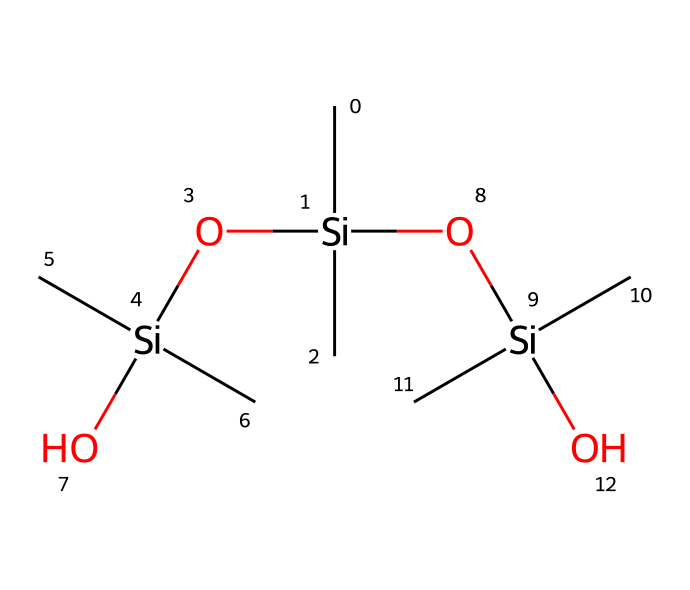What is the main functional group present in this chemical? The chemical structure contains multiple silicon atoms bonded to oxygen atoms, which is characteristic of silanol functional groups. The oxygen bonded to silicon indicates the presence of these groups.
Answer: silanol How many silicon atoms are present in the chemical structure? By analyzing the SMILES representation, we can identify three silicon atoms indicated by the notation 'Si'. Counting each instance yields a total of three silicon atoms.
Answer: three What type of chemical bond connects the silicon and oxygen atoms? The connection between silicon and oxygen atoms in this compound is characterized by covalent bonds, which are indicated in the chemical structure where silicon and oxygen are directly bonded.
Answer: covalent What is the total number of hydroxyl groups in this compound? The presence of hydroxyl groups (-OH) can be determined by looking for the oxygen atoms that are connected to hydrogen. Here, there are three hydroxyl groups attached to the silicon.
Answer: three How does this molecular arrangement contribute to the properties of microphone diaphragms? The branched structure and the presence of silanol groups enhance the flexibility and resilience of the material, which is crucial for sound capturing in microphone diaphragms, providing better acoustic properties.
Answer: flexibility 